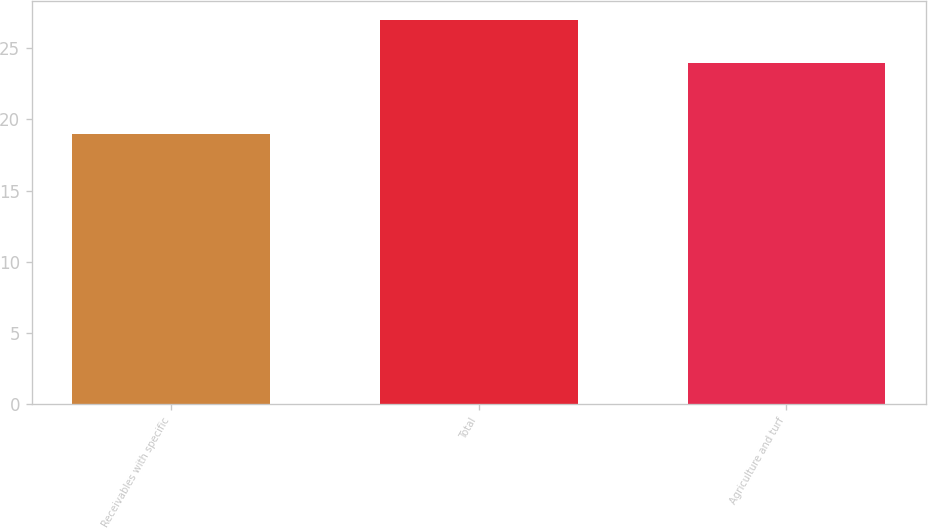Convert chart to OTSL. <chart><loc_0><loc_0><loc_500><loc_500><bar_chart><fcel>Receivables with specific<fcel>Total<fcel>Agriculture and turf<nl><fcel>19<fcel>27<fcel>24<nl></chart> 